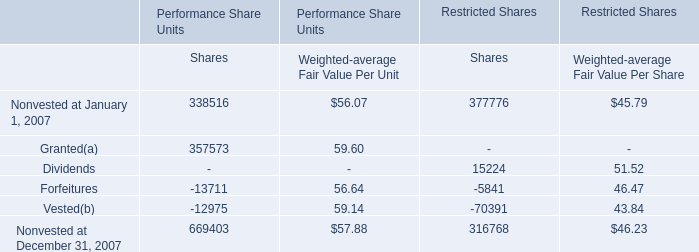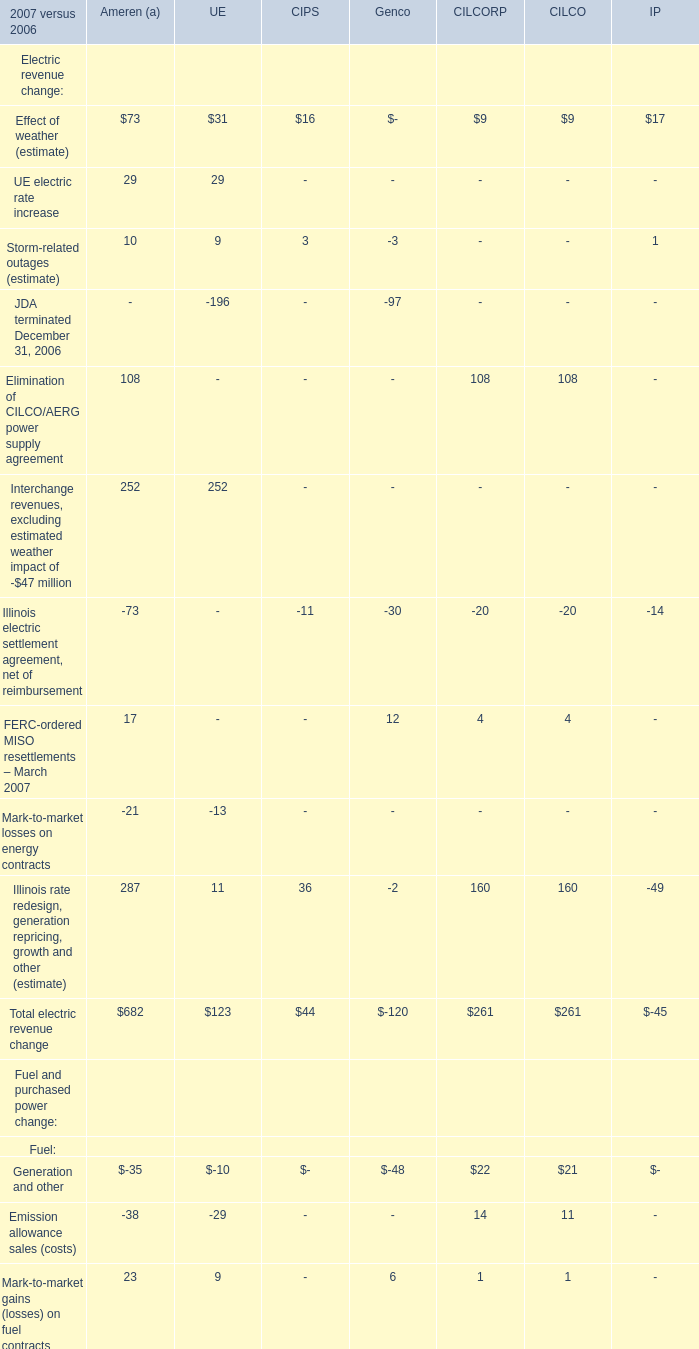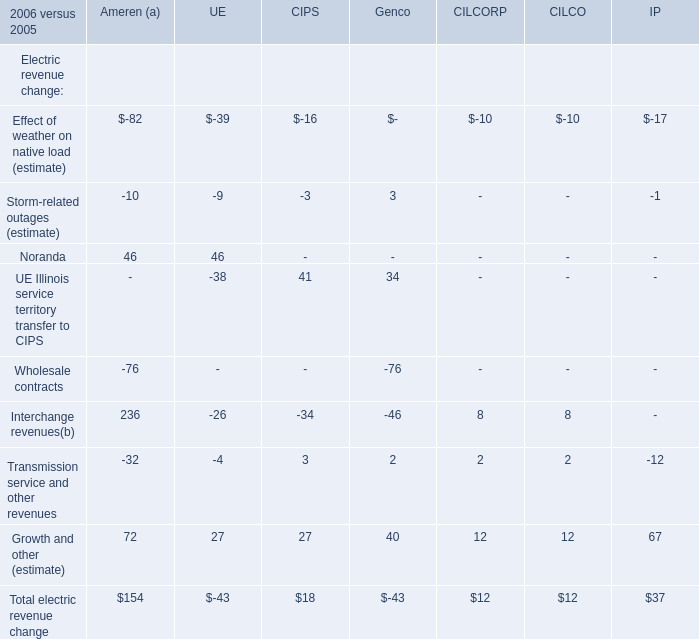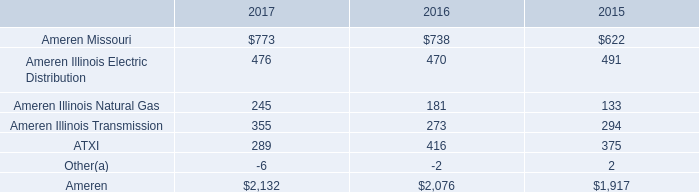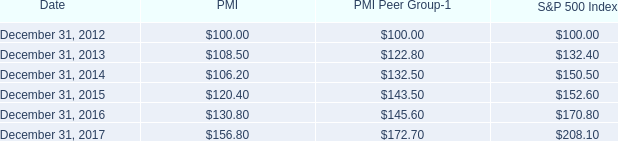What's the total amount of the Ameren (a) in the years where Total electric revenue change is greater than 100? 
Answer: 154. 